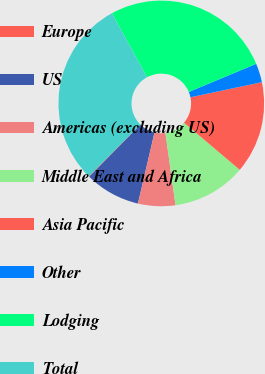<chart> <loc_0><loc_0><loc_500><loc_500><pie_chart><fcel>Europe<fcel>US<fcel>Americas (excluding US)<fcel>Middle East and Africa<fcel>Asia Pacific<fcel>Other<fcel>Lodging<fcel>Total<nl><fcel>0.1%<fcel>8.73%<fcel>5.86%<fcel>11.61%<fcel>14.49%<fcel>2.98%<fcel>26.68%<fcel>29.56%<nl></chart> 